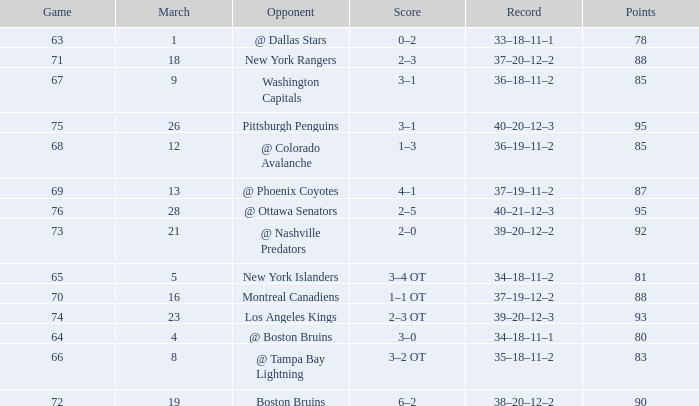Which Opponent has a Record of 38–20–12–2? Boston Bruins. 